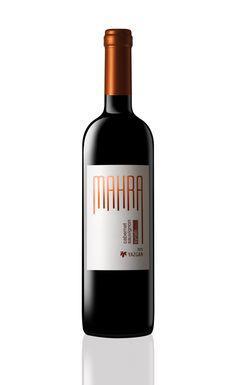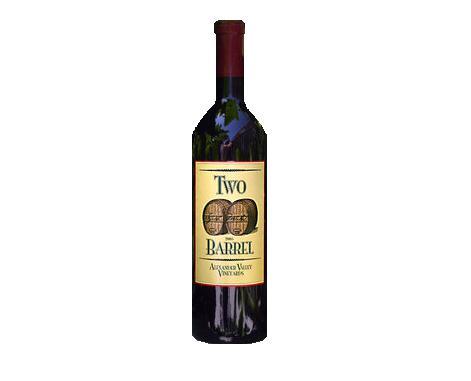The first image is the image on the left, the second image is the image on the right. For the images displayed, is the sentence "There is at least 1 wine bottle with a red cap." factually correct? Answer yes or no. Yes. The first image is the image on the left, the second image is the image on the right. Analyze the images presented: Is the assertion "at least one bottle has a tan colored top" valid? Answer yes or no. No. 